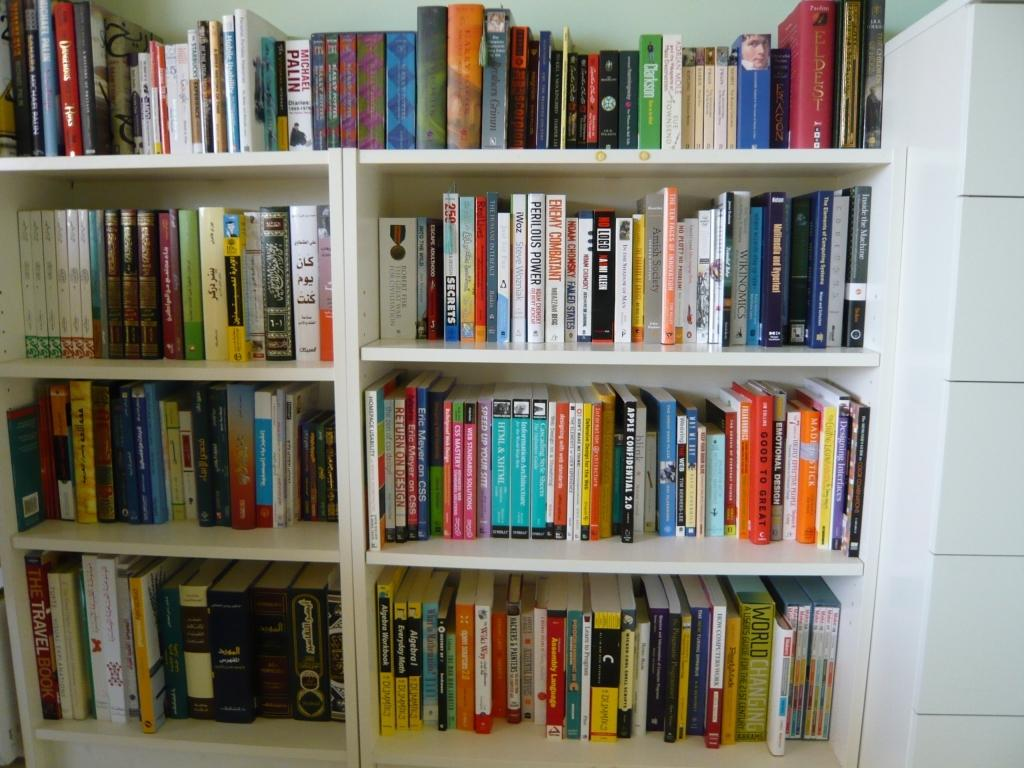What is on the racks in the image? There are racks with books in the image. How many books are on the racks? The racks are filled with many books. What color is the wall on the right side of the image? There is a white wall on the right side of the image. What is visible in the background of the image? There is a white wall in the background of the image. What type of insurance is being discussed by the books on the racks? There is no indication in the image that the books are discussing any type of insurance. 